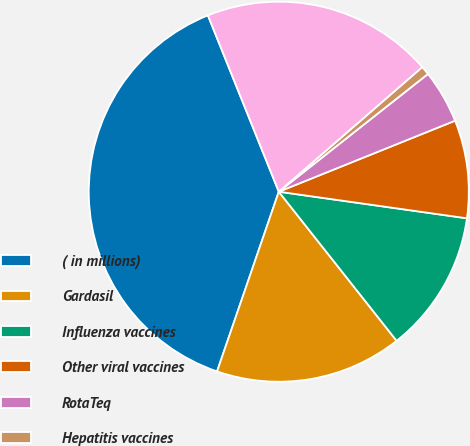Convert chart to OTSL. <chart><loc_0><loc_0><loc_500><loc_500><pie_chart><fcel>( in millions)<fcel>Gardasil<fcel>Influenza vaccines<fcel>Other viral vaccines<fcel>RotaTeq<fcel>Hepatitis vaccines<fcel>Other vaccines<nl><fcel>38.65%<fcel>15.91%<fcel>12.12%<fcel>8.33%<fcel>4.54%<fcel>0.75%<fcel>19.7%<nl></chart> 